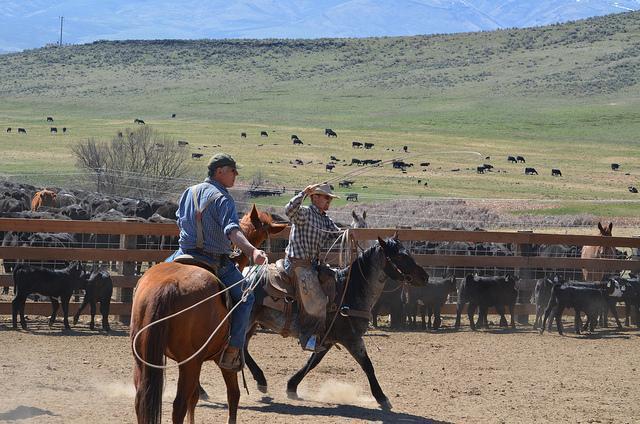How many men have on hats?
Give a very brief answer. 2. How many people do you see?
Give a very brief answer. 2. How many riders are mounted on these horses?
Give a very brief answer. 2. How many cows are there?
Give a very brief answer. 3. How many horses are there?
Give a very brief answer. 2. How many people can you see?
Give a very brief answer. 2. 